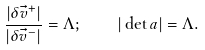Convert formula to latex. <formula><loc_0><loc_0><loc_500><loc_500>\frac { | \delta \vec { v } ^ { + } | } { | \delta \vec { v } ^ { - } | } = \Lambda ; \quad | \det { a } | = \Lambda .</formula> 